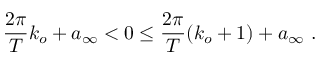<formula> <loc_0><loc_0><loc_500><loc_500>\frac { 2 \pi } { T } k _ { o } + a _ { \infty } < 0 \leq \frac { 2 \pi } { T } ( k _ { o } + 1 ) + a _ { \infty } \ .</formula> 